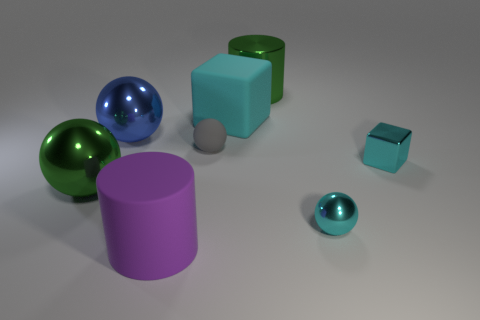Subtract all gray rubber spheres. How many spheres are left? 3 Subtract all blue spheres. How many spheres are left? 3 Add 2 large things. How many objects exist? 10 Subtract all cubes. How many objects are left? 6 Subtract 1 cubes. How many cubes are left? 1 Subtract all yellow blocks. Subtract all brown cylinders. How many blocks are left? 2 Subtract all gray cubes. How many green spheres are left? 1 Subtract all large cyan rubber balls. Subtract all metal cubes. How many objects are left? 7 Add 5 green spheres. How many green spheres are left? 6 Add 6 small metallic spheres. How many small metallic spheres exist? 7 